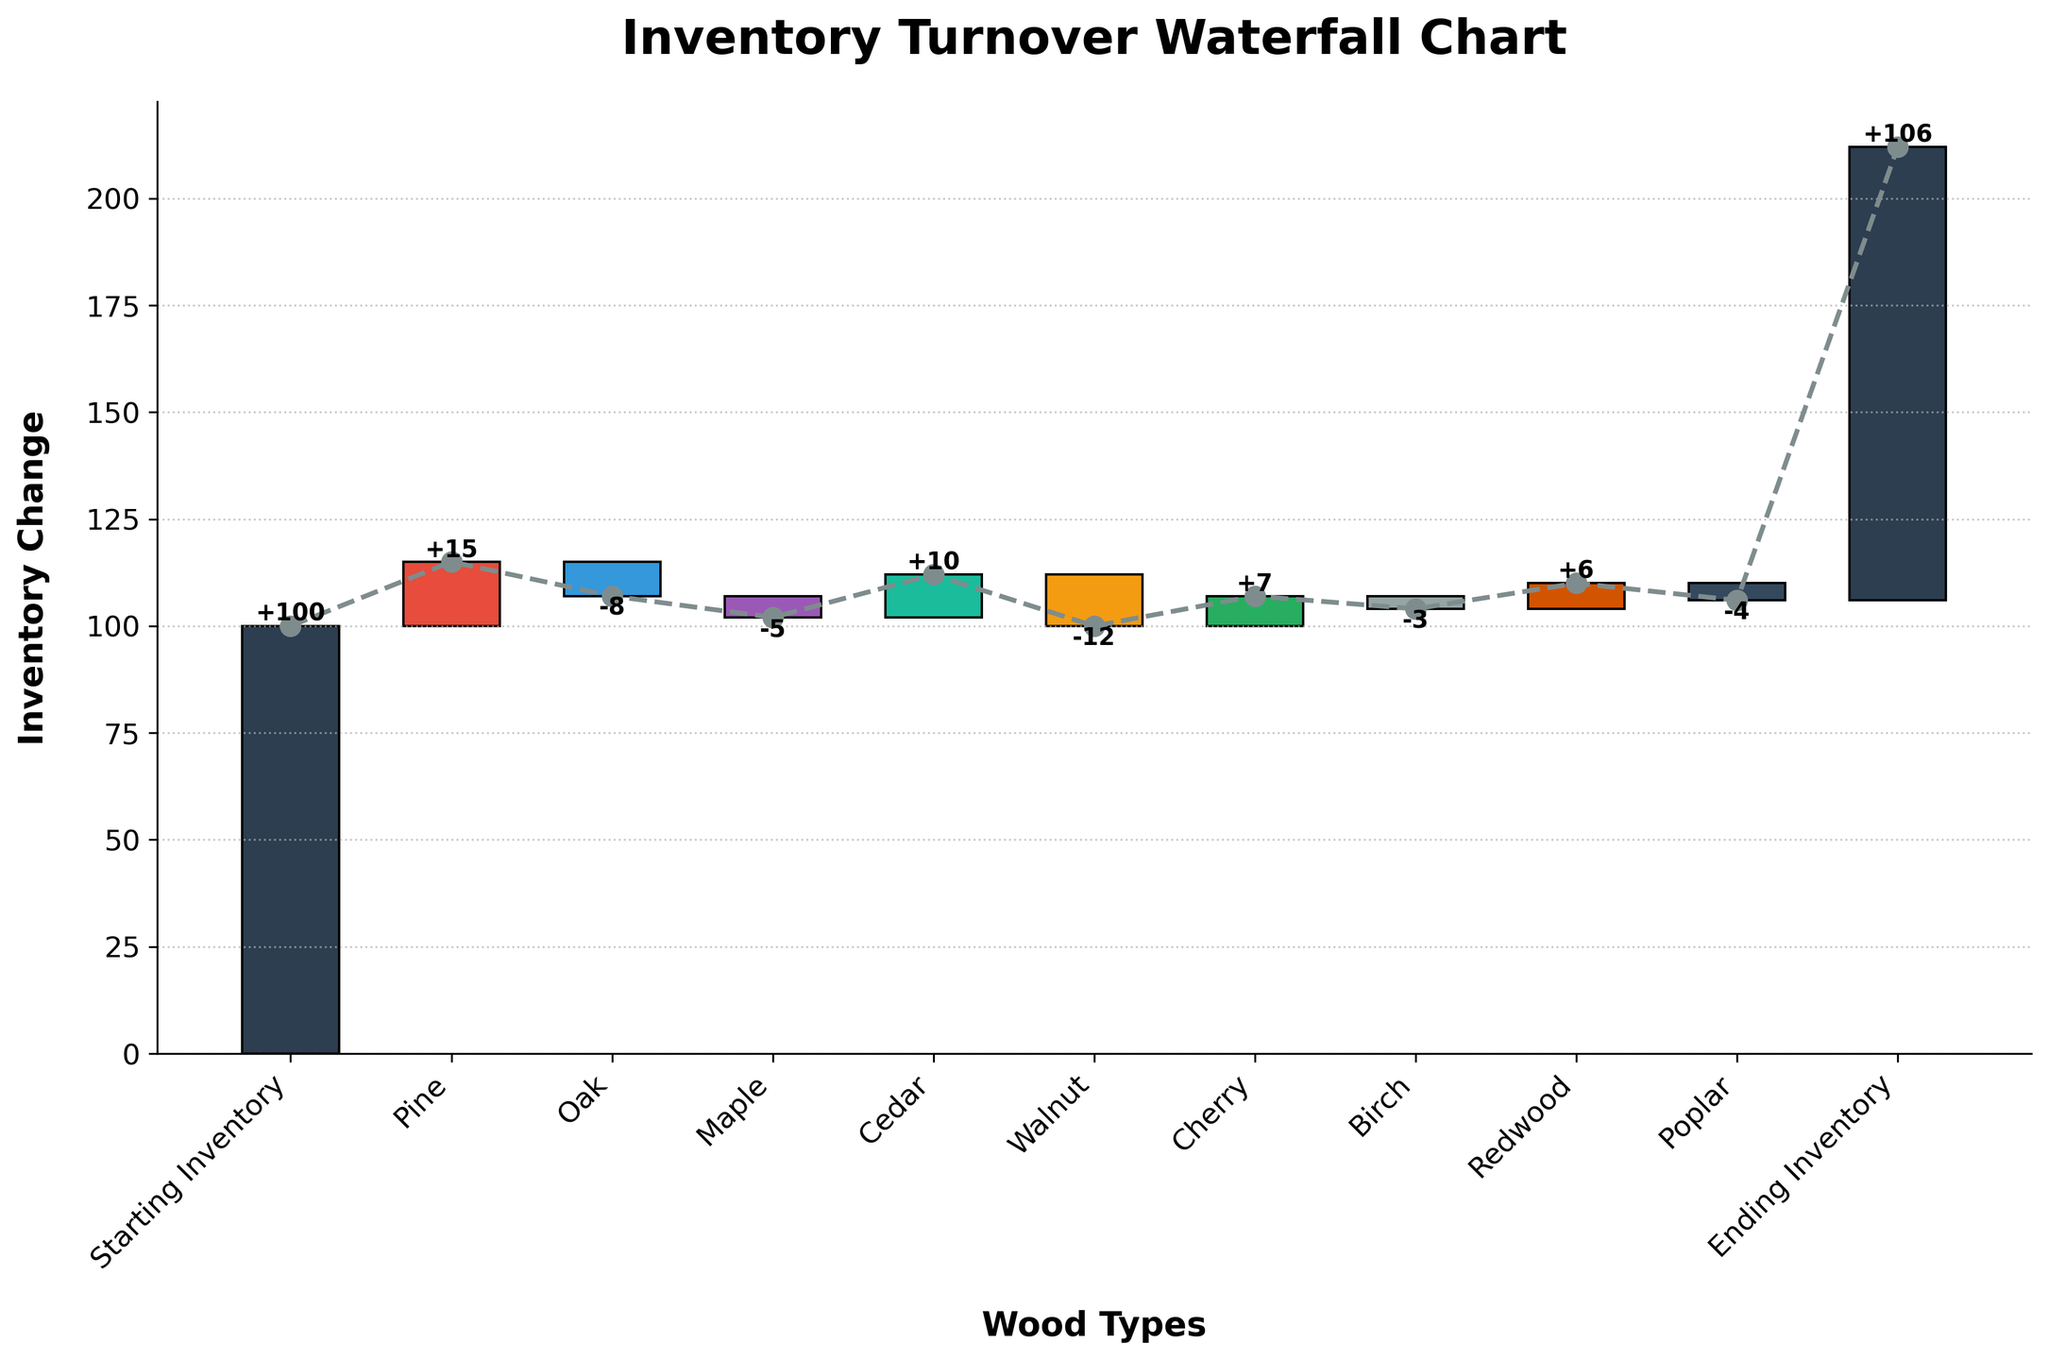What is the title of the chart? The title is displayed at the top of the chart, usually in a larger and bold font, indicating the main topic of the chart. In this case, it is "Inventory Turnover Waterfall Chart."
Answer: Inventory Turnover Waterfall Chart What is the starting inventory value? The starting inventory value is the first data point in the waterfall chart, listed at the beginning as "Starting Inventory."
Answer: 100 Which wood type had the highest positive inventory change? To determine this, look at the bars where the value increases and check the height. The wood type with the highest positive value is Pine with a change of +15.
Answer: Pine What is the ending inventory value? The ending inventory value is the last data point in the waterfall chart, listed at the end as "Ending Inventory."
Answer: 106 How much did the inventory change for Oak? The inventory change for Oak is shown as a negative value next to its bar, which is -8.
Answer: -8 What is the total inventory change from the starting to the ending inventory? To find the total inventory change, subtract the starting inventory from the ending inventory (106 - 100).
Answer: 6 Which wood type had the largest negative impact on inventory? To find this, look for the wood type with the lowest (most negative) value, which is Walnut with a change of -12.
Answer: Walnut Between Maple and Cedar, which had a higher inventory change, and by how much? Compare the inventory changes listed for Maple (-5) and Cedar (+10). Cedar had a higher inventory change. The difference is 10 - (-5) = 15.
Answer: Cedar by 15 What is the cumulative inventory after accounting for Pine and Oak? Start from the initial value (100), add Pine's change (+15), then subtract Oak's change (-8). The cumulative inventory is 100 + 15 - 8 = 107.
Answer: 107 How many wood types contributed to positive inventory changes? Count the wood types with positive values: Pine, Cedar, Cherry, and Redwood. There are 4 wood types with positive changes.
Answer: 4 